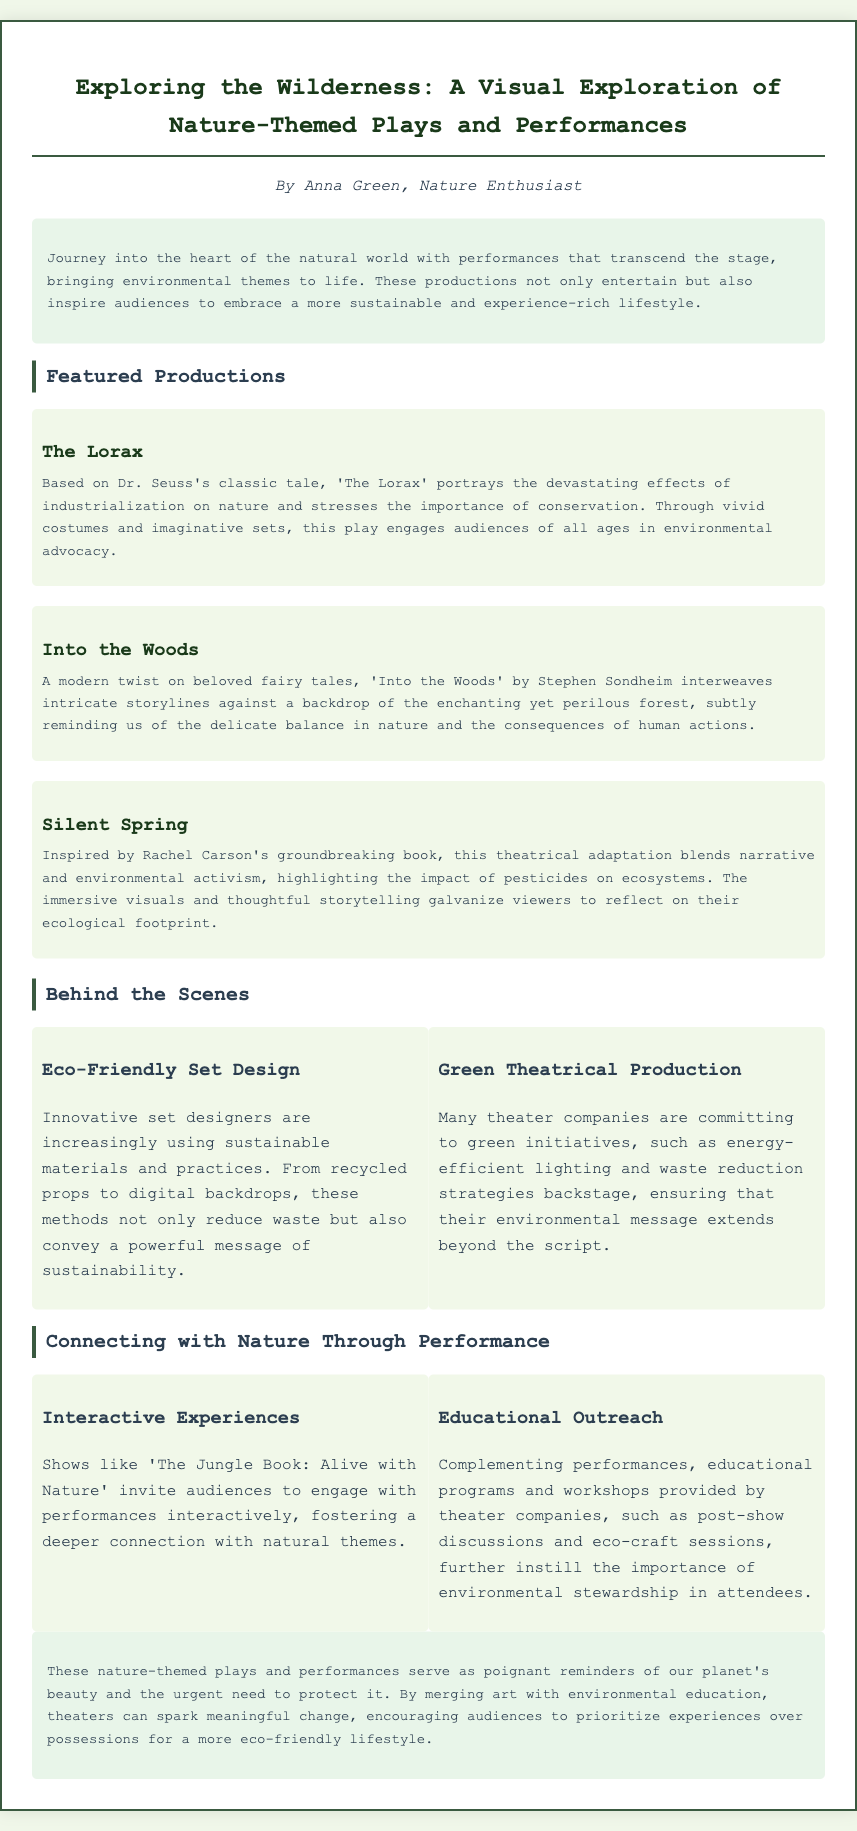What is the title of the Playbill? The title appears prominently at the top of the document, highlighting the main theme of the content.
Answer: Exploring the Wilderness: A Visual Exploration of Nature-Themed Plays and Performances Who is the author of the Playbill? The author's name is stated under the title, indicating the individual behind the content.
Answer: Anna Green What is one of the featured productions mentioned? The document lists several productions, specifically titles that align with ecological themes.
Answer: The Lorax What is the focus of 'Silent Spring'? The description provides insight into the themes and inspirations behind the specific production.
Answer: Impact of pesticides on ecosystems What are two aspects of eco-friendly set design? The behind-the-scenes section discusses sustainable practices and materials used in productions.
Answer: Recycled props and digital backdrops What type of audience engagement does 'The Jungle Book: Alive with Nature' promote? This part of the document emphasizes the interactive nature of specific performances and their connections to environmental themes.
Answer: Interactive experiences What is the purpose of educational outreach in theater? The document explains the role of educational programs that complement performances, reinforcing environmental messages.
Answer: Instill environmental stewardship Which production is based on a book by Rachel Carson? The featured production section clearly specifies which play draws inspiration from a well-known environmentalist's work.
Answer: Silent Spring What green initiative is mentioned for theater companies? The behind-the-scenes section includes details regarding specific eco-friendly commitments made by theaters.
Answer: Energy-efficient lighting 